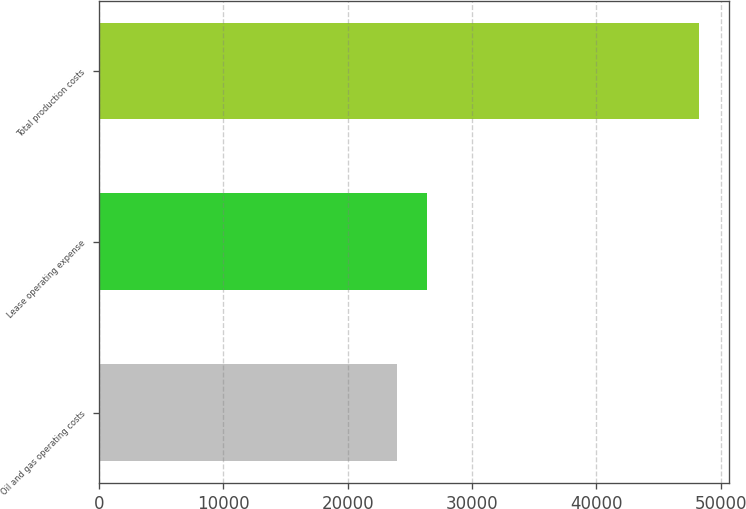<chart> <loc_0><loc_0><loc_500><loc_500><bar_chart><fcel>Oil and gas operating costs<fcel>Lease operating expense<fcel>Total production costs<nl><fcel>23978<fcel>26405<fcel>48248<nl></chart> 